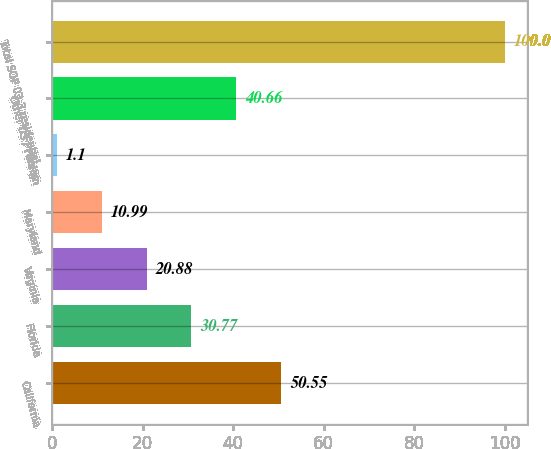<chart> <loc_0><loc_0><loc_500><loc_500><bar_chart><fcel>California<fcel>Florida<fcel>Virginia<fcel>Maryland<fcel>Texas<fcel>Other US / Foreign<fcel>Total SOP 03-3 residential<nl><fcel>50.55<fcel>30.77<fcel>20.88<fcel>10.99<fcel>1.1<fcel>40.66<fcel>100<nl></chart> 